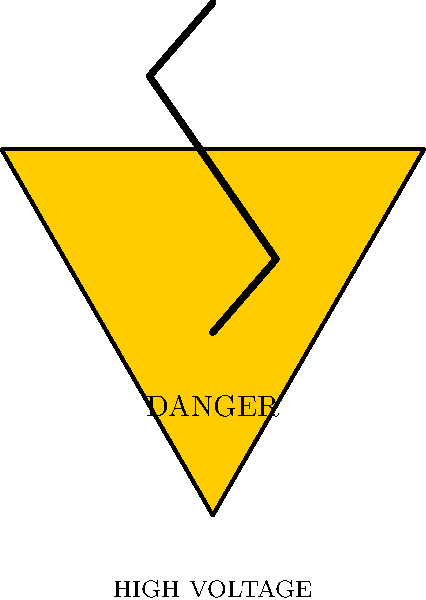As an overseas business development executive visiting a construction site, you encounter the symbol shown above. What does this symbol indicate, and what immediate action should you take upon seeing it? To answer this question, let's break down the components of the symbol and their meanings:

1. Triangle shape: In safety signage, a triangle typically indicates a warning or danger.

2. Yellow color: Yellow is universally used to signify caution or warning.

3. Black border: The black border enhances visibility and emphasizes the warning nature of the sign.

4. Lightning bolt symbol: This represents electricity or high voltage.

5. Text "DANGER" and "HIGH VOLTAGE": These words explicitly state the nature of the hazard.

Putting these elements together, we can conclude that this symbol indicates the presence of high-voltage electrical equipment or systems in the area.

The immediate action to take upon seeing this symbol is to:

1. Stop and do not proceed further towards the area marked with this sign.
2. Stay at a safe distance from the marked area or equipment.
3. Do not touch any equipment or surfaces near the sign.
4. Alert any accompanying personnel about the danger.
5. If you need to access the area, seek guidance from a qualified electrician or site safety officer.

As a business development executive, it's crucial to respect these safety warnings to ensure your personal safety and demonstrate your company's commitment to following safety protocols on construction sites.
Answer: Danger: High voltage area. Stop, maintain safe distance, and seek guidance if access is necessary. 